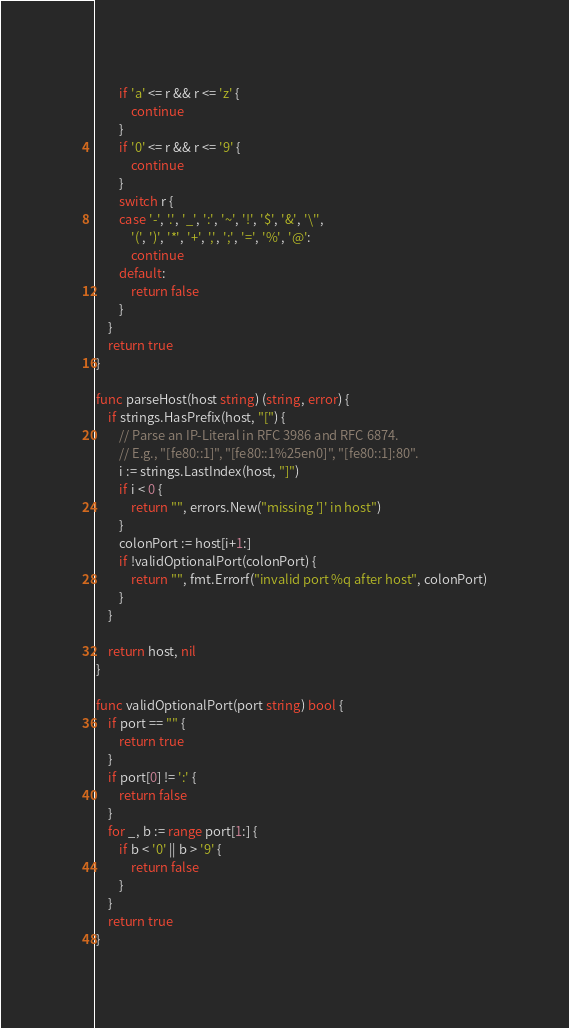<code> <loc_0><loc_0><loc_500><loc_500><_Go_>		if 'a' <= r && r <= 'z' {
			continue
		}
		if '0' <= r && r <= '9' {
			continue
		}
		switch r {
		case '-', '.', '_', ':', '~', '!', '$', '&', '\'',
			'(', ')', '*', '+', ',', ';', '=', '%', '@':
			continue
		default:
			return false
		}
	}
	return true
}

func parseHost(host string) (string, error) {
	if strings.HasPrefix(host, "[") {
		// Parse an IP-Literal in RFC 3986 and RFC 6874.
		// E.g., "[fe80::1]", "[fe80::1%25en0]", "[fe80::1]:80".
		i := strings.LastIndex(host, "]")
		if i < 0 {
			return "", errors.New("missing ']' in host")
		}
		colonPort := host[i+1:]
		if !validOptionalPort(colonPort) {
			return "", fmt.Errorf("invalid port %q after host", colonPort)
		}
	}

	return host, nil
}

func validOptionalPort(port string) bool {
	if port == "" {
		return true
	}
	if port[0] != ':' {
		return false
	}
	for _, b := range port[1:] {
		if b < '0' || b > '9' {
			return false
		}
	}
	return true
}
</code> 